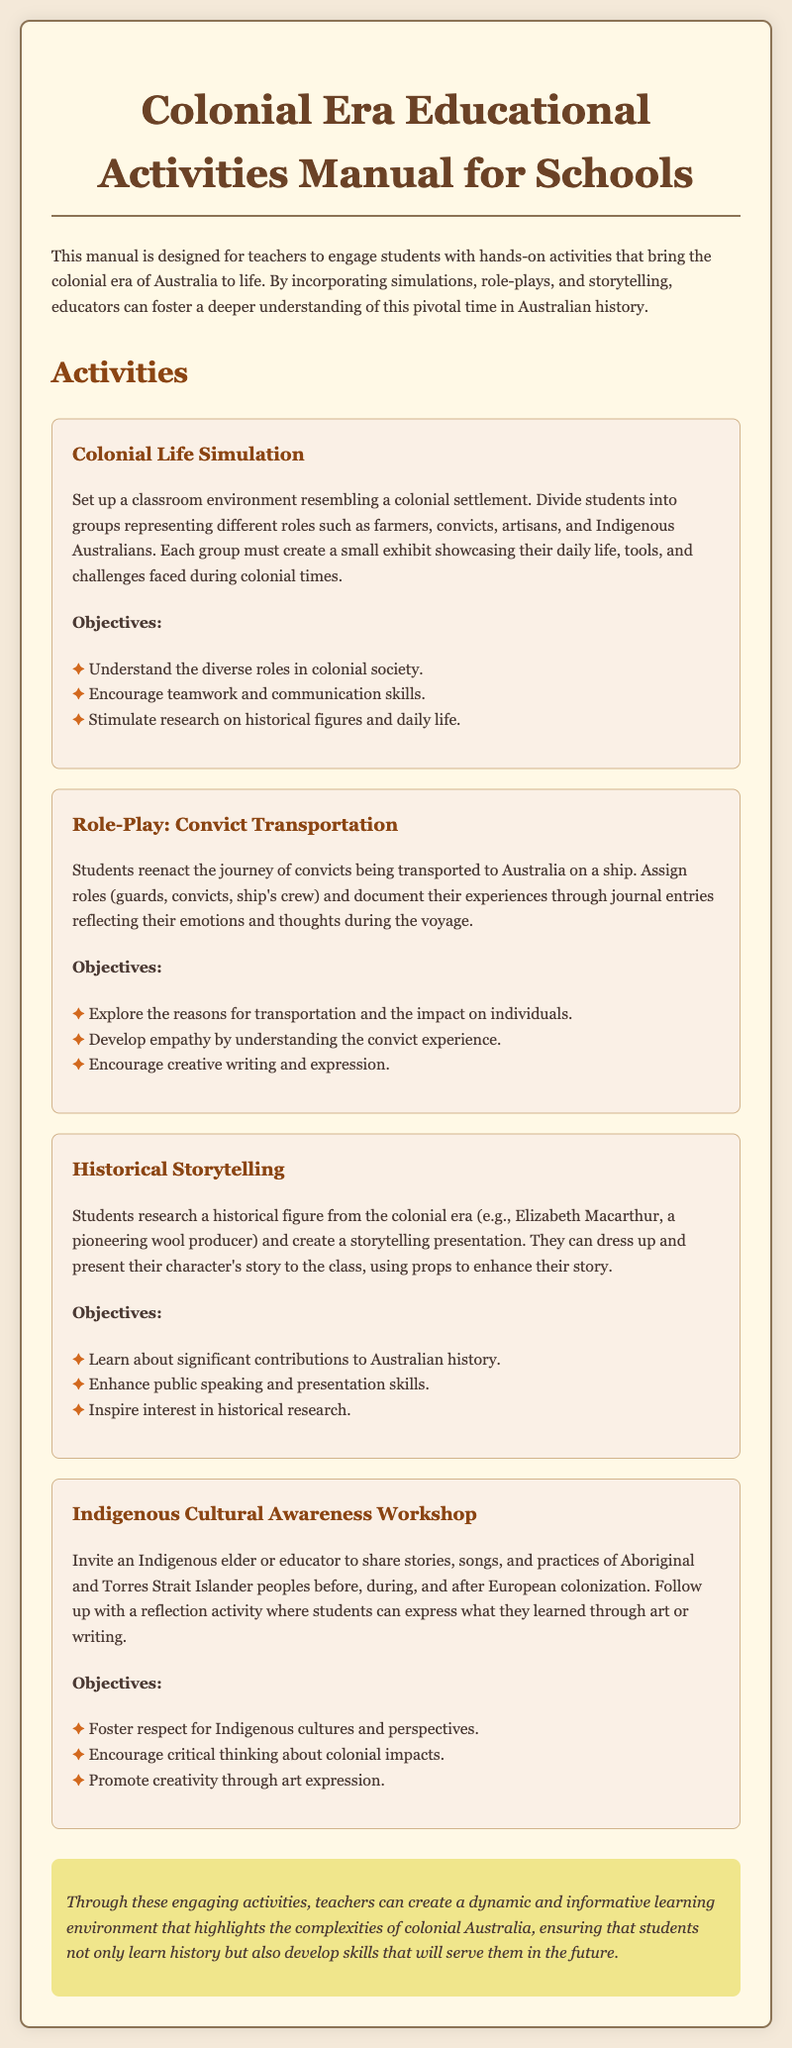What is the title of the manual? The title of the manual is prominently displayed at the top of the document.
Answer: Colonial Era Educational Activities Manual for Schools How many activities are listed in the manual? The manual provides a list of different activities that engage students. Counting those activities gives a total.
Answer: Four Who is an example of a historical figure mentioned in the storytelling activity? The storytelling activity specifies a historical figure for students to research and present.
Answer: Elizabeth Macarthur What is one objective of the Indigenous Cultural Awareness Workshop? The workshop has specific objectives outlined in the document to promote learning and respect.
Answer: Foster respect for Indigenous cultures and perspectives What type of simulation is suggested for students to engage with colonial life? The manual describes a specific type of activity that immerses students in historical context.
Answer: Colonial Life Simulation What is one medium students can use to express their learning after the Indigenous workshop? The reflection activity described in the workshop allows for various forms of expression.
Answer: Art or writing What role do students take in the Convict Transportation role-play? Students are assigned different roles in the reenactment of a historical event involving convicts.
Answer: Guards, convicts, ship's crew 